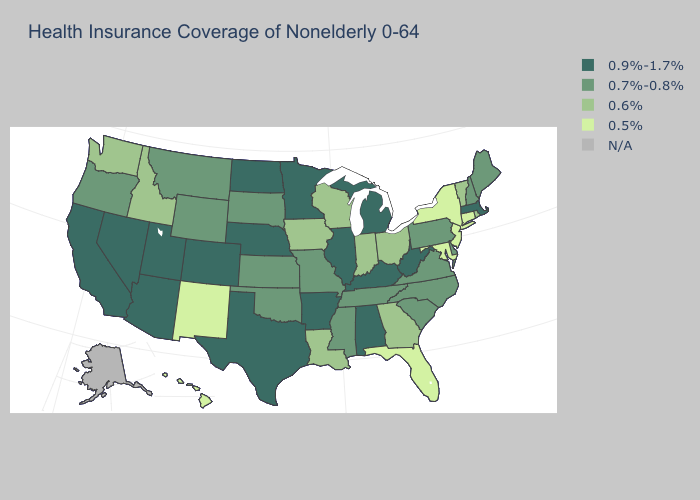What is the lowest value in the MidWest?
Short answer required. 0.6%. Which states have the highest value in the USA?
Give a very brief answer. Alabama, Arizona, Arkansas, California, Colorado, Illinois, Kentucky, Massachusetts, Michigan, Minnesota, Nebraska, Nevada, North Dakota, Texas, Utah, West Virginia. What is the lowest value in the USA?
Answer briefly. 0.5%. What is the lowest value in states that border Maryland?
Be succinct. 0.7%-0.8%. Which states have the lowest value in the West?
Write a very short answer. Hawaii, New Mexico. Which states have the lowest value in the USA?
Answer briefly. Connecticut, Florida, Hawaii, Maryland, New Jersey, New Mexico, New York. What is the lowest value in the MidWest?
Write a very short answer. 0.6%. Name the states that have a value in the range 0.7%-0.8%?
Be succinct. Delaware, Kansas, Maine, Mississippi, Missouri, Montana, New Hampshire, North Carolina, Oklahoma, Oregon, Pennsylvania, South Carolina, South Dakota, Tennessee, Virginia, Wyoming. Name the states that have a value in the range 0.6%?
Answer briefly. Georgia, Idaho, Indiana, Iowa, Louisiana, Ohio, Rhode Island, Vermont, Washington, Wisconsin. Which states hav the highest value in the South?
Write a very short answer. Alabama, Arkansas, Kentucky, Texas, West Virginia. Among the states that border Utah , which have the lowest value?
Answer briefly. New Mexico. What is the lowest value in states that border Colorado?
Answer briefly. 0.5%. Does Minnesota have the highest value in the USA?
Give a very brief answer. Yes. Among the states that border Rhode Island , which have the lowest value?
Give a very brief answer. Connecticut. What is the highest value in the USA?
Quick response, please. 0.9%-1.7%. 